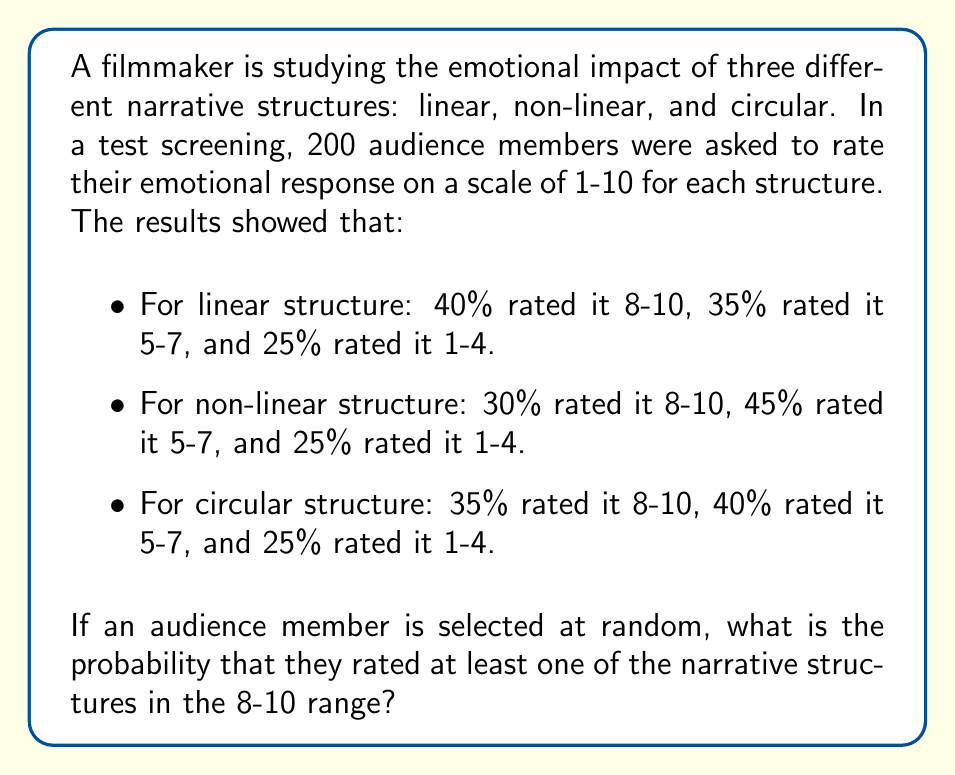Teach me how to tackle this problem. To solve this problem, we need to use the concept of probability of union events and the complementary probability.

Let's define the events:
A: The audience member rated the linear structure 8-10
B: The audience member rated the non-linear structure 8-10
C: The audience member rated the circular structure 8-10

We want to find P(A ∪ B ∪ C), which is the probability that at least one of these events occurred.

It's easier to calculate the complement of this probability, which is the probability that none of these events occurred, and then subtract it from 1.

P(A ∪ B ∪ C) = 1 - P(A' ∩ B' ∩ C')

Where A', B', and C' are the complements of A, B, and C respectively.

P(A') = 1 - 0.40 = 0.60
P(B') = 1 - 0.30 = 0.70
P(C') = 1 - 0.35 = 0.65

Assuming independence between the ratings for different structures:

P(A' ∩ B' ∩ C') = P(A') × P(B') × P(C')
                = 0.60 × 0.70 × 0.65
                = 0.273

Therefore:

P(A ∪ B ∪ C) = 1 - P(A' ∩ B' ∩ C')
              = 1 - 0.273
              = 0.727
Answer: The probability that a randomly selected audience member rated at least one of the narrative structures in the 8-10 range is approximately 0.727 or 72.7%. 